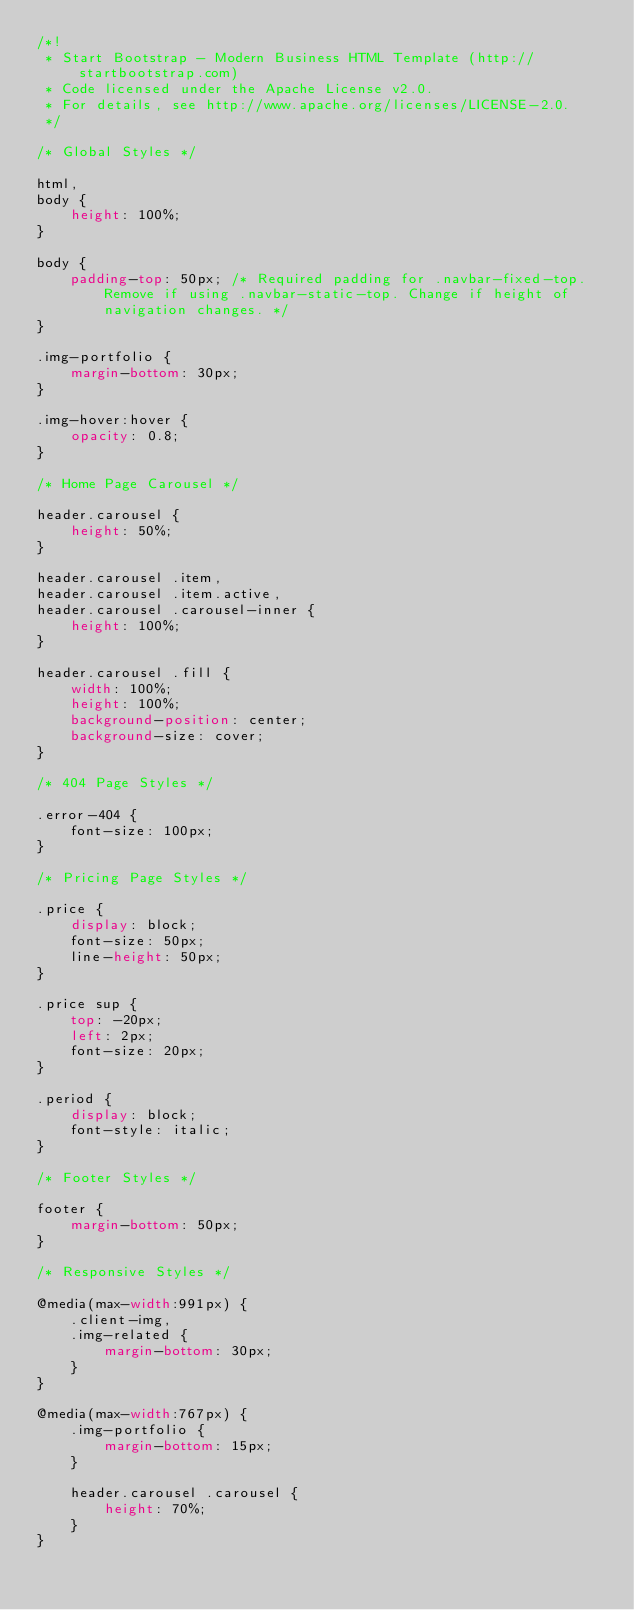<code> <loc_0><loc_0><loc_500><loc_500><_CSS_>/*!
 * Start Bootstrap - Modern Business HTML Template (http://startbootstrap.com)
 * Code licensed under the Apache License v2.0.
 * For details, see http://www.apache.org/licenses/LICENSE-2.0.
 */

/* Global Styles */

html,
body {
    height: 100%;
}

body {
    padding-top: 50px; /* Required padding for .navbar-fixed-top. Remove if using .navbar-static-top. Change if height of navigation changes. */
}

.img-portfolio {
    margin-bottom: 30px;
}

.img-hover:hover {
    opacity: 0.8;
}

/* Home Page Carousel */

header.carousel {
    height: 50%;
}

header.carousel .item,
header.carousel .item.active,
header.carousel .carousel-inner {
    height: 100%;
}

header.carousel .fill {
    width: 100%;
    height: 100%;
    background-position: center;
    background-size: cover;
}

/* 404 Page Styles */

.error-404 {
    font-size: 100px;
}

/* Pricing Page Styles */

.price {
    display: block;
    font-size: 50px;
    line-height: 50px;
}

.price sup {
    top: -20px;
    left: 2px;
    font-size: 20px;
}

.period {
    display: block;
    font-style: italic;
}

/* Footer Styles */

footer {
    margin-bottom: 50px;
}

/* Responsive Styles */

@media(max-width:991px) {
    .client-img,
    .img-related {
        margin-bottom: 30px;
    }
}

@media(max-width:767px) {
    .img-portfolio {
        margin-bottom: 15px;
    }

    header.carousel .carousel {
        height: 70%;
    }
}</code> 